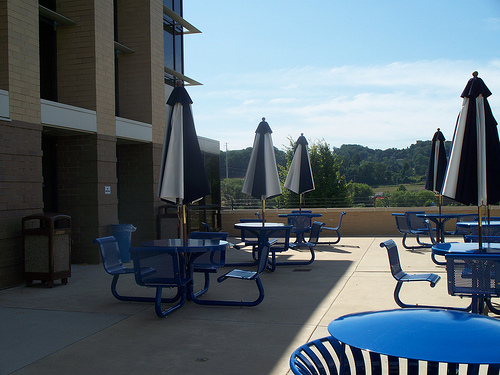<image>
Is the building in front of the table? Yes. The building is positioned in front of the table, appearing closer to the camera viewpoint. 